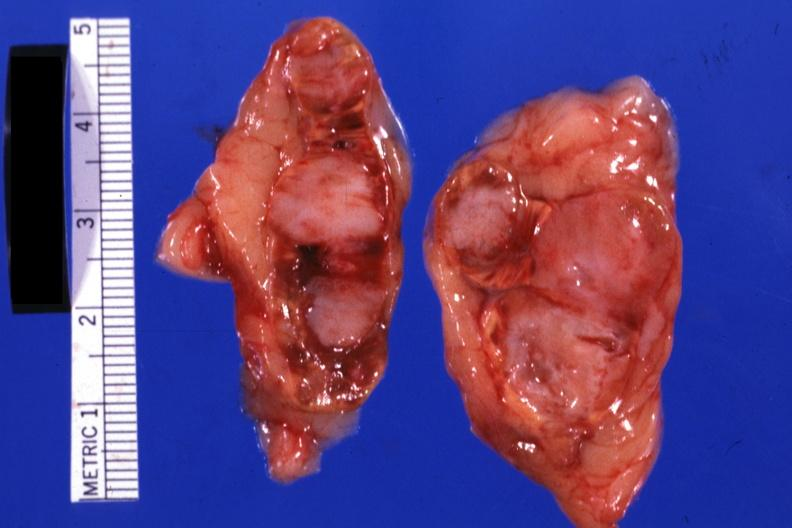s metastatic carcinoma lung present?
Answer the question using a single word or phrase. Yes 